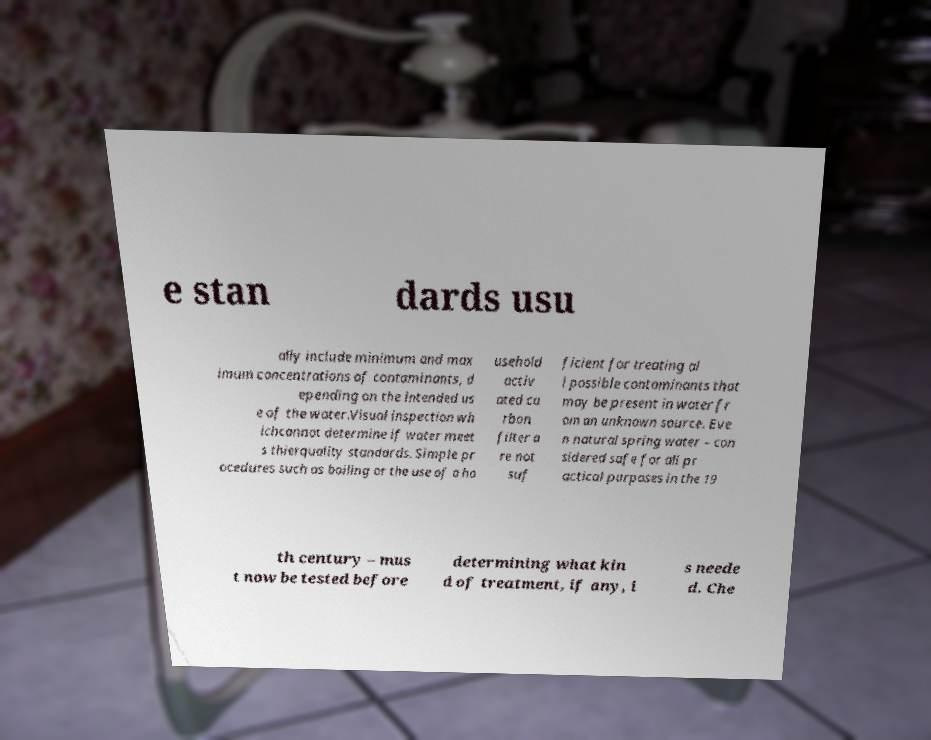What messages or text are displayed in this image? I need them in a readable, typed format. e stan dards usu ally include minimum and max imum concentrations of contaminants, d epending on the intended us e of the water.Visual inspection wh ichcannot determine if water meet s thierquality standards. Simple pr ocedures such as boiling or the use of a ho usehold activ ated ca rbon filter a re not suf ficient for treating al l possible contaminants that may be present in water fr om an unknown source. Eve n natural spring water – con sidered safe for all pr actical purposes in the 19 th century – mus t now be tested before determining what kin d of treatment, if any, i s neede d. Che 